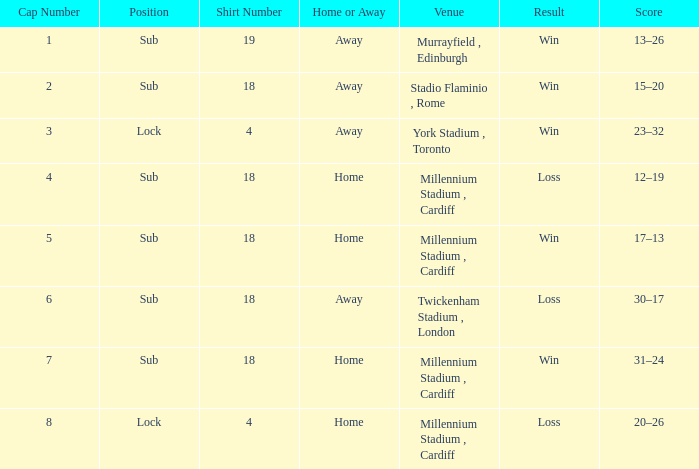On november 13, 2009, what was the winning score in the game? 17–13. 